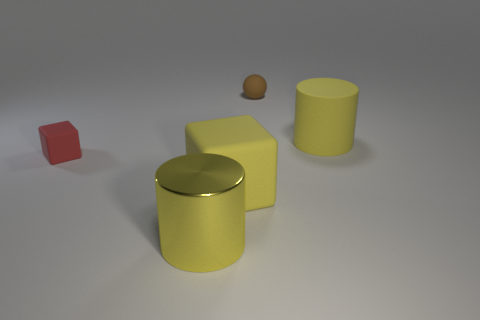Add 4 red cylinders. How many objects exist? 9 Subtract all spheres. How many objects are left? 4 Add 4 big yellow cubes. How many big yellow cubes are left? 5 Add 1 big objects. How many big objects exist? 4 Subtract 0 blue spheres. How many objects are left? 5 Subtract all tiny yellow things. Subtract all tiny brown balls. How many objects are left? 4 